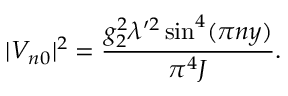Convert formula to latex. <formula><loc_0><loc_0><loc_500><loc_500>| V _ { n 0 } | ^ { 2 } = \frac { g _ { 2 } ^ { 2 } \lambda ^ { \prime 2 } \sin ^ { 4 } ( \pi n y ) } { \pi ^ { 4 } J } .</formula> 